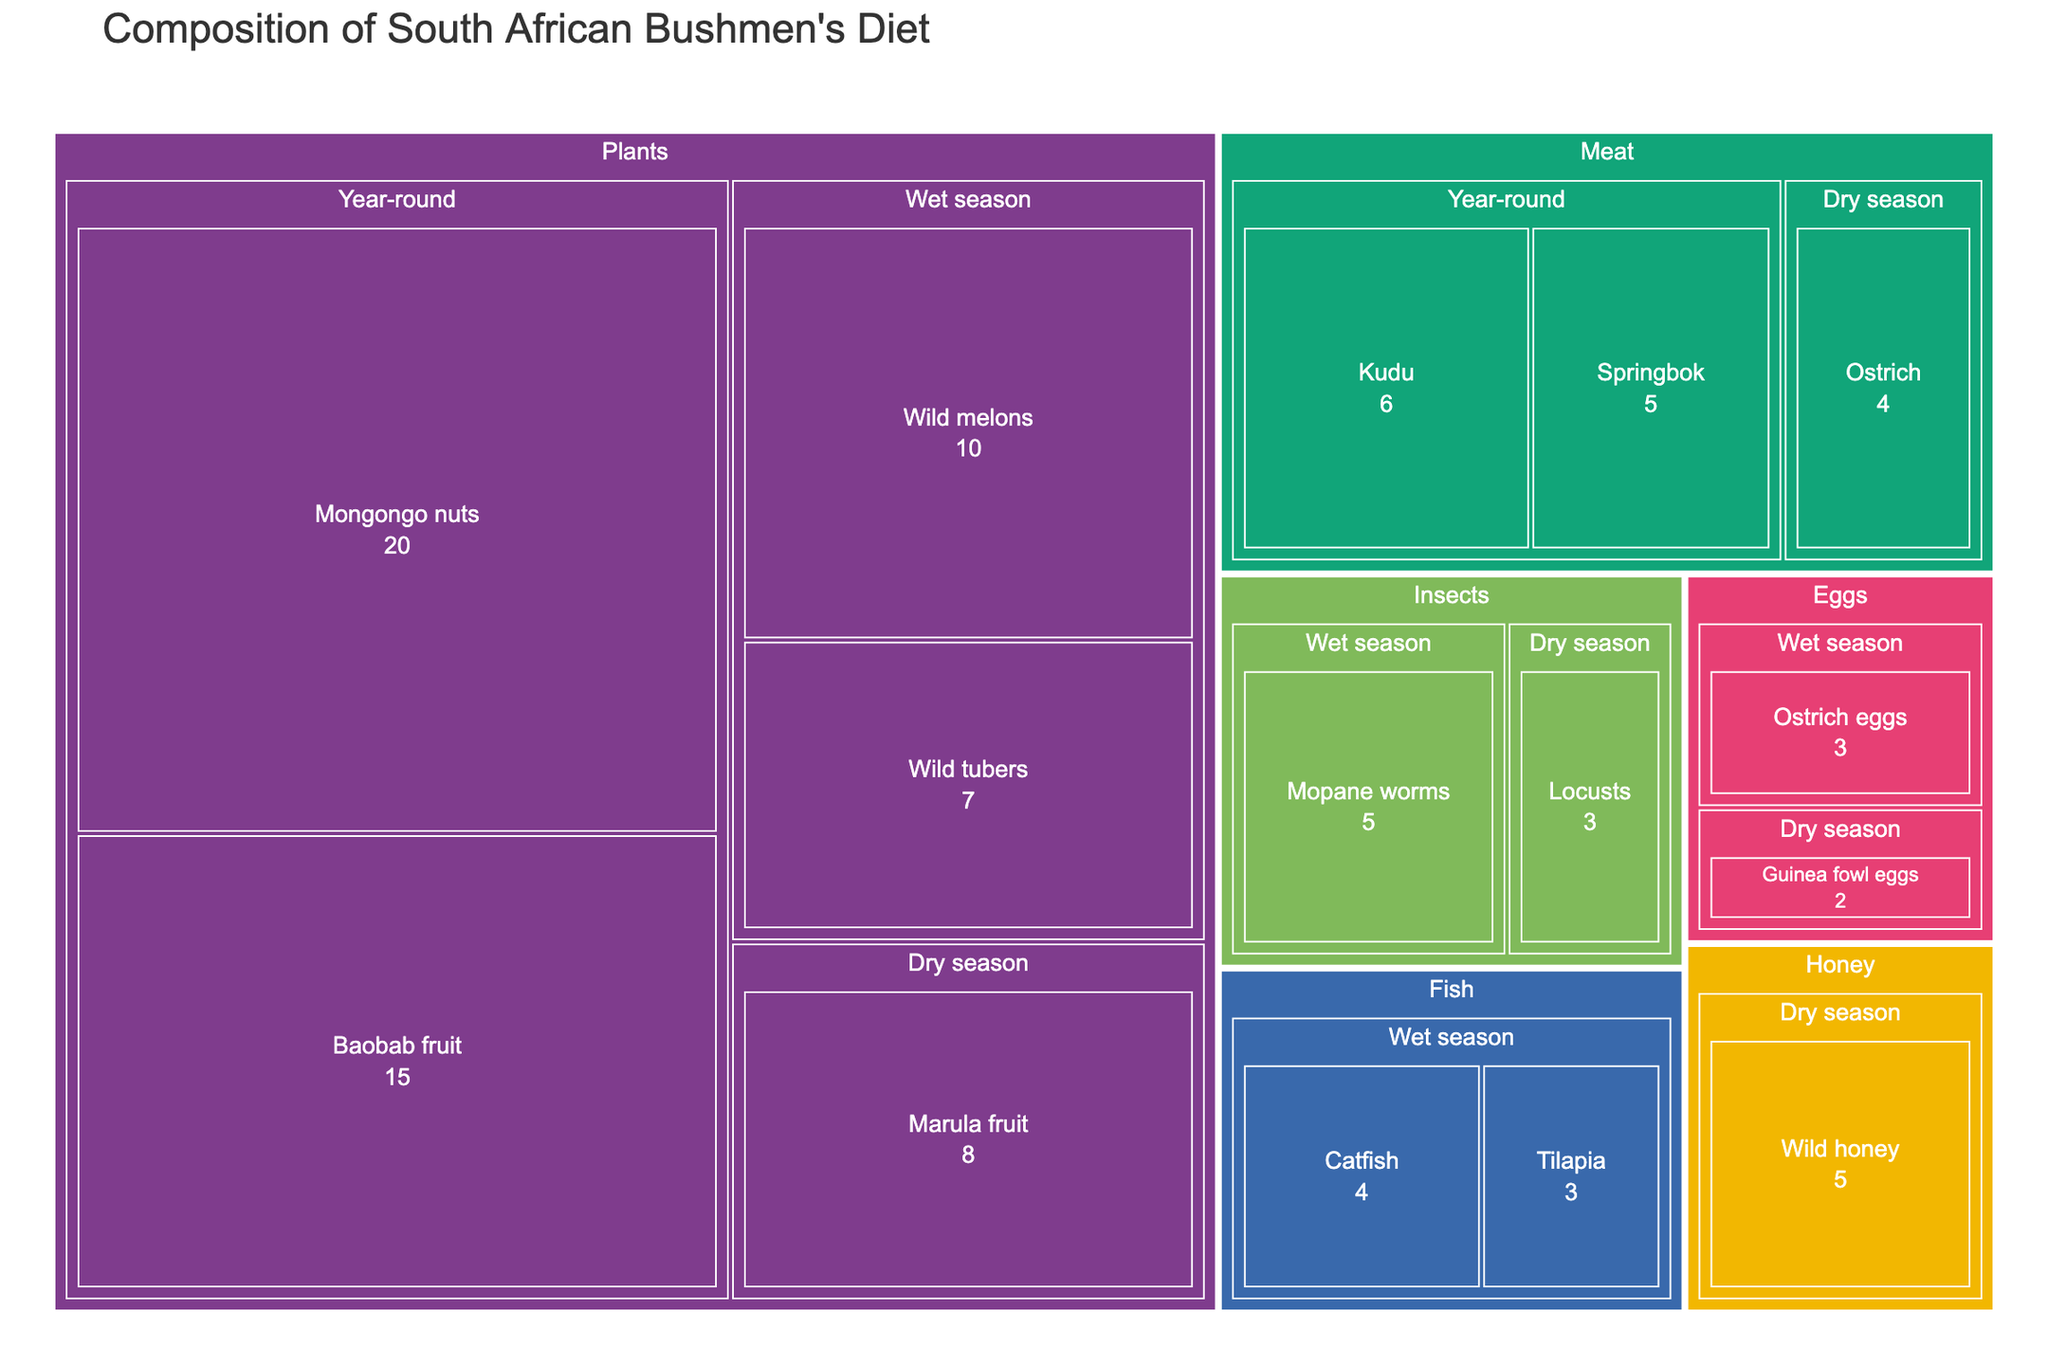Which food group has the highest percentage in the bushmen's diet? The treemap shows different food groups and their respective percentages. The food group with the largest area, visually representing the highest percentage, is 'Plants'.
Answer: Plants What is the title of the treemap? The title is always displayed at the top of the treemap. For this treemap, it is 'Composition of South African Bushmen's Diet'.
Answer: Composition of South African Bushmen's Diet Which food item has the highest percentage in the 'Plants' group? Within the 'Plants' group, the item with the largest area represents the highest percentage, which is 'Mongongo nuts'.
Answer: Mongongo nuts How many food items are available year-round? The treemap show items under the 'Year-round' season. Counting these items gives 'Mongongo nuts', 'Baobab fruit', 'Kudu', and 'Springbok', leading to four items.
Answer: 4 What is the combined percentage of foods available in the wet season? Summing the percentages of items available in the wet season: Wild melons (10) + Wild tubers (7) + Mopane worms (5) + Catfish (4) + Tilapia (3) + Ostrich eggs (3) results in 10 + 7 + 5 + 4 + 3 + 3 = 32%.
Answer: 32% How does the percentage of 'Ostrich' in the 'Meat' group compare between the dry and wet seasons? The treemap shows 'Ostrich' only in the dry season with a percentage of 4%. There is no occurrence of 'Ostrich' in the wet season.
Answer: Only in dry season, 4% Which items are part of the 'Insects' group and what is their combined percentage? The items in the 'Insects' group are 'Mopane worms' and 'Locusts'. Adding their percentages: Mopane worms (5) + Locusts (3) results in 5 + 3 = 8%.
Answer: Mopane worms and Locusts, 8% Which season has a higher availability of fish? The treemap shows 'Catfish' and 'Tilapia', both appearing in the wet season. There are no fish items in the dry season. Thus, the wet season has higher availability.
Answer: Wet season What is the percentage difference between 'Marula fruit' and 'Wild honey'? The percentage of 'Marula fruit' is 8% and 'Wild honey' is 5%. The difference is calculated as 8 - 5 = 3%.
Answer: 3% If the consumption percentages remain the same, how would the diet composition change seasonally? The treemap shows some items being specific to either the wet or dry season and some available year-round. The diet composition would shift seasonally, relying more on available seasonal items like 'Wild melons' in the wet season and 'Marula fruit' in the dry season.
Answer: Seasonal shift based on item availability 